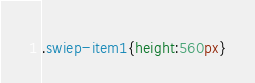Convert code to text. <code><loc_0><loc_0><loc_500><loc_500><_CSS_>.swiep-item1{height:560px}</code> 